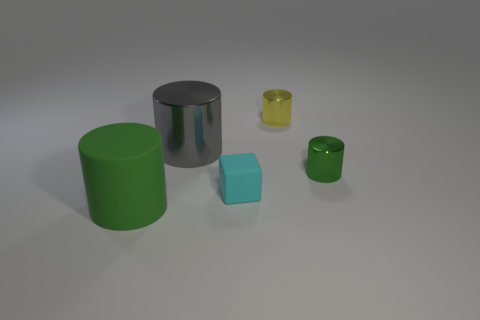What shape is the green object that is the same material as the large gray cylinder?
Provide a short and direct response. Cylinder. Is the green object that is behind the cyan cube made of the same material as the big gray cylinder?
Make the answer very short. Yes. What number of other objects are there of the same material as the small cyan cube?
Offer a terse response. 1. What number of objects are either small cylinders in front of the large metal cylinder or metal objects that are right of the big green rubber object?
Keep it short and to the point. 3. There is a small cyan object in front of the small green metal cylinder; does it have the same shape as the green object that is to the right of the large green cylinder?
Keep it short and to the point. No. There is a green object that is the same size as the yellow metallic object; what is its shape?
Keep it short and to the point. Cylinder. What number of matte things are green things or cyan blocks?
Provide a succinct answer. 2. Is the cylinder in front of the tiny rubber thing made of the same material as the green cylinder that is right of the small yellow thing?
Your answer should be very brief. No. The cylinder that is made of the same material as the cube is what color?
Keep it short and to the point. Green. Are there more cylinders that are in front of the gray metal thing than small cyan matte objects to the left of the matte cube?
Give a very brief answer. Yes. 